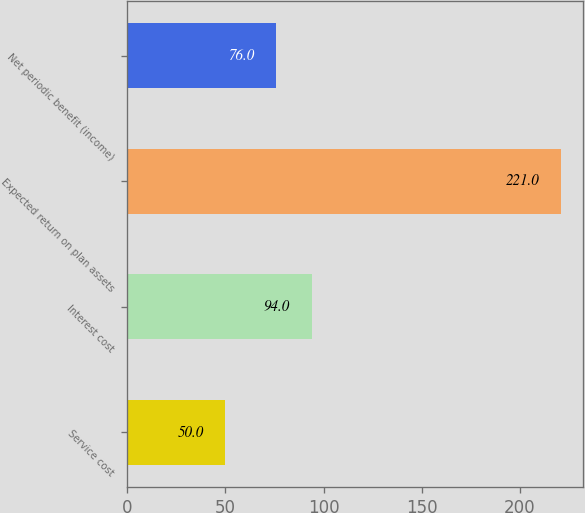<chart> <loc_0><loc_0><loc_500><loc_500><bar_chart><fcel>Service cost<fcel>Interest cost<fcel>Expected return on plan assets<fcel>Net periodic benefit (income)<nl><fcel>50<fcel>94<fcel>221<fcel>76<nl></chart> 